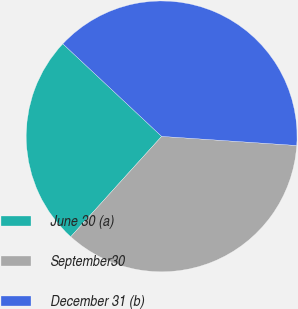Convert chart to OTSL. <chart><loc_0><loc_0><loc_500><loc_500><pie_chart><fcel>June 30 (a)<fcel>September30<fcel>December 31 (b)<nl><fcel>25.27%<fcel>35.64%<fcel>39.09%<nl></chart> 